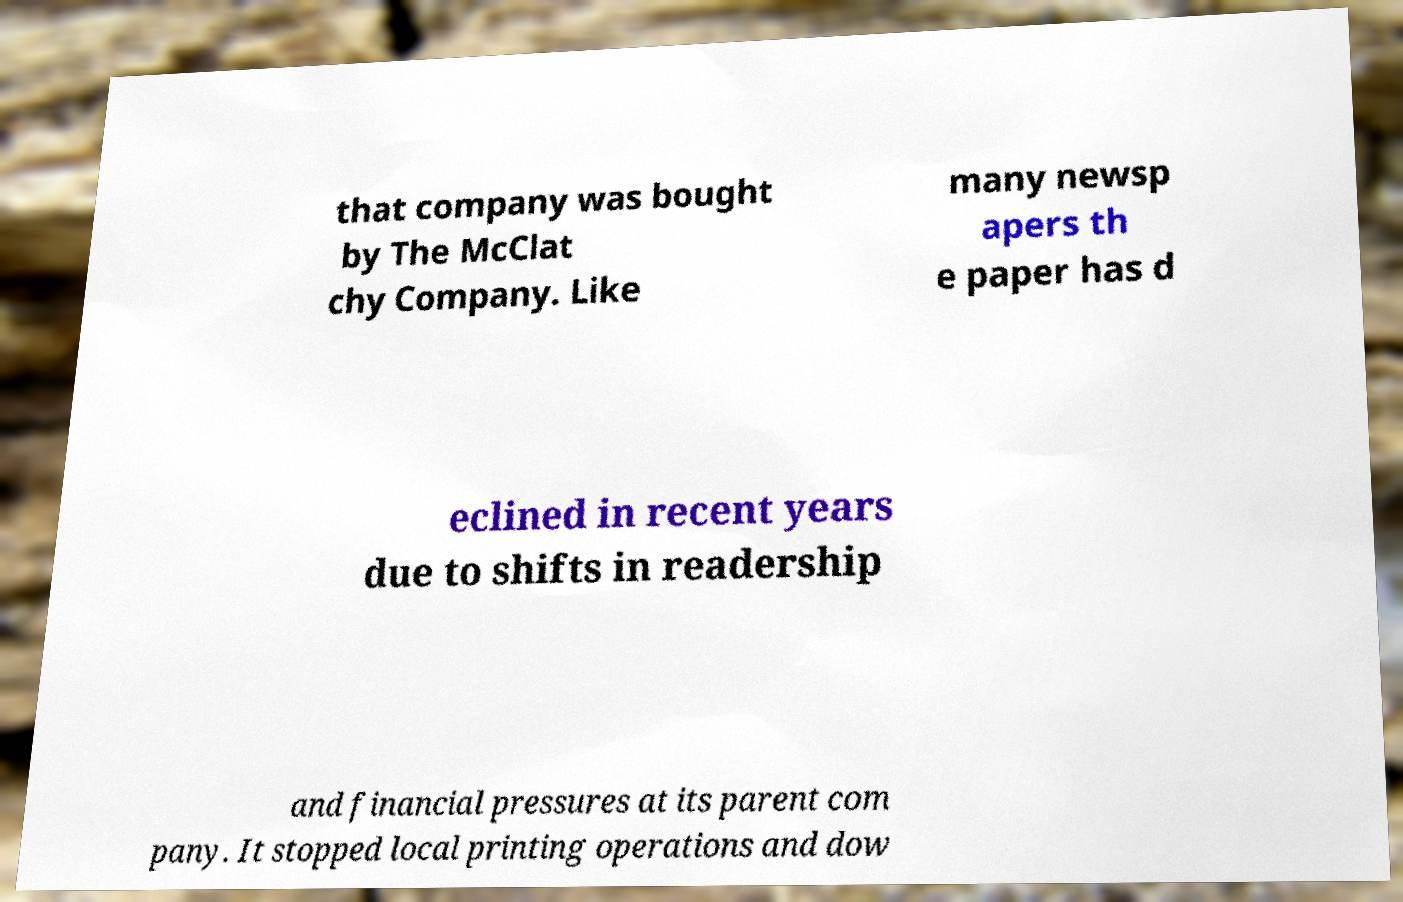Can you accurately transcribe the text from the provided image for me? that company was bought by The McClat chy Company. Like many newsp apers th e paper has d eclined in recent years due to shifts in readership and financial pressures at its parent com pany. It stopped local printing operations and dow 